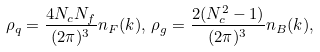<formula> <loc_0><loc_0><loc_500><loc_500>\rho _ { q } = \frac { 4 N _ { c } N _ { f } } { ( 2 \pi ) ^ { 3 } } n _ { F } ( k ) , \, \rho _ { g } = \frac { 2 ( N ^ { 2 } _ { c } - 1 ) } { ( 2 \pi ) ^ { 3 } } n _ { B } ( k ) ,</formula> 